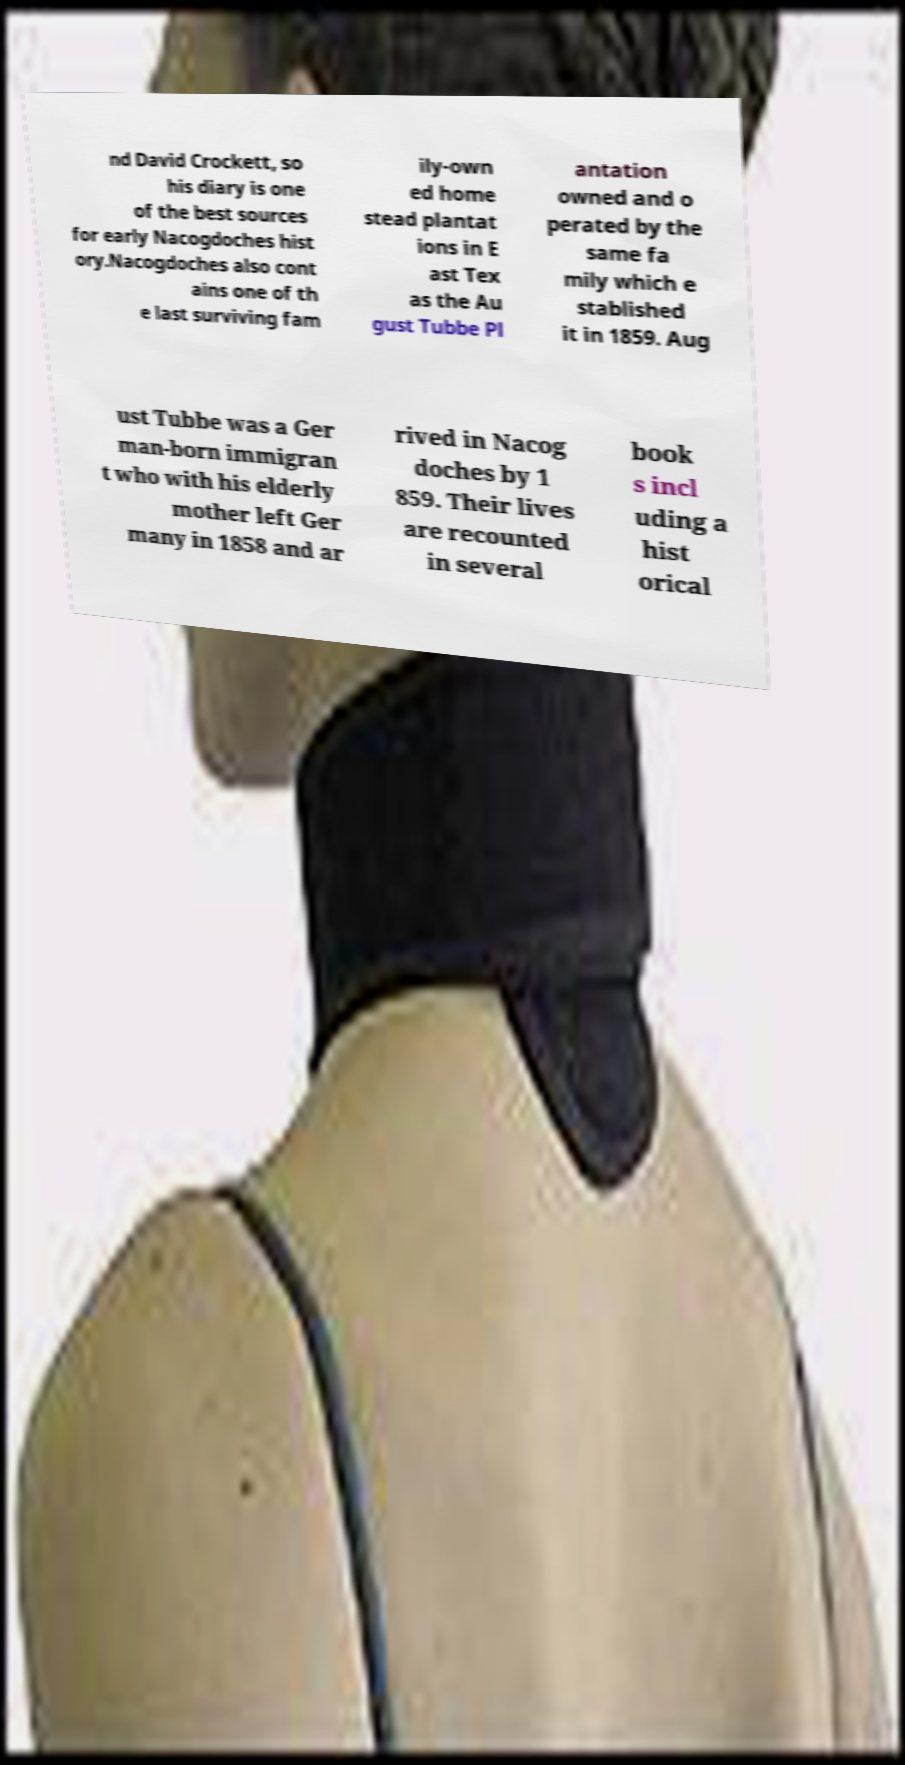What messages or text are displayed in this image? I need them in a readable, typed format. nd David Crockett, so his diary is one of the best sources for early Nacogdoches hist ory.Nacogdoches also cont ains one of th e last surviving fam ily-own ed home stead plantat ions in E ast Tex as the Au gust Tubbe Pl antation owned and o perated by the same fa mily which e stablished it in 1859. Aug ust Tubbe was a Ger man-born immigran t who with his elderly mother left Ger many in 1858 and ar rived in Nacog doches by 1 859. Their lives are recounted in several book s incl uding a hist orical 